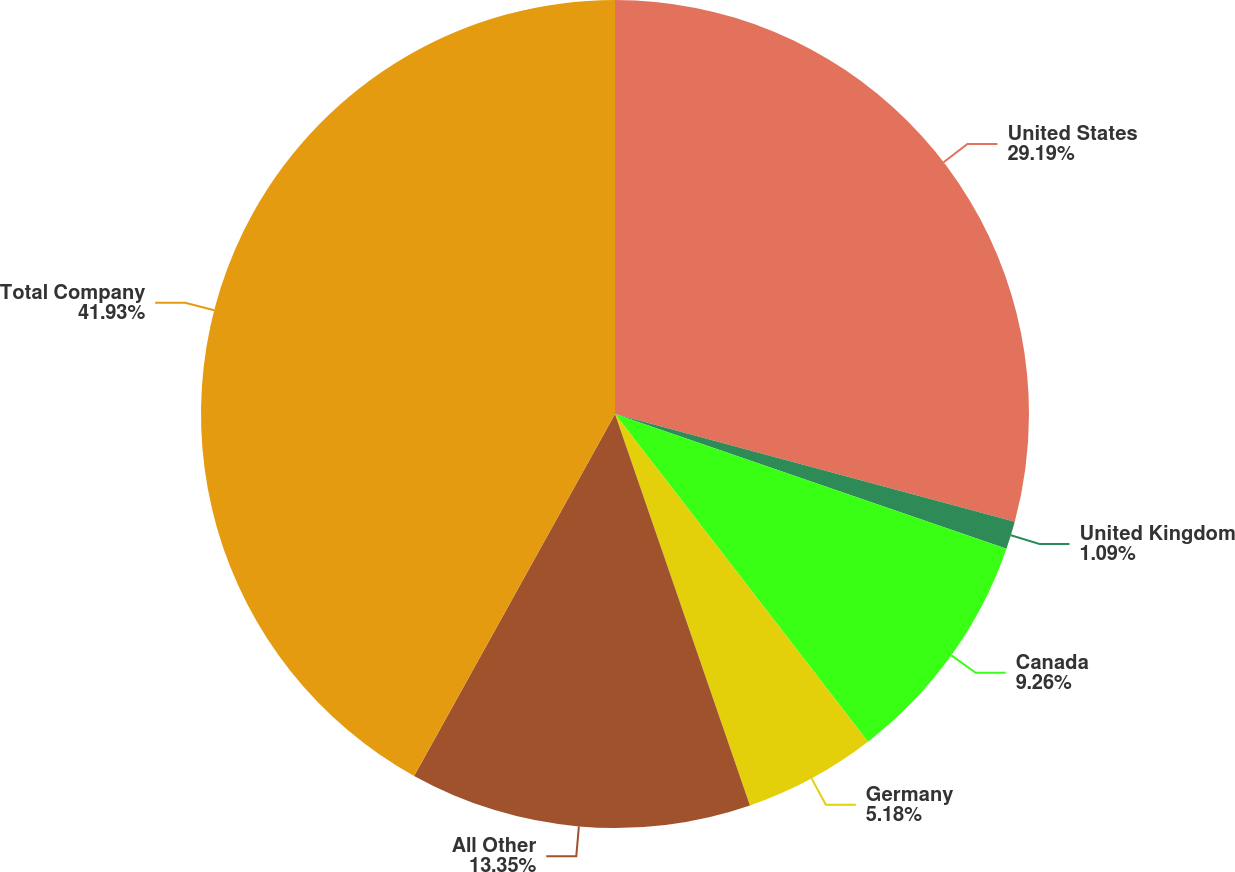<chart> <loc_0><loc_0><loc_500><loc_500><pie_chart><fcel>United States<fcel>United Kingdom<fcel>Canada<fcel>Germany<fcel>All Other<fcel>Total Company<nl><fcel>29.19%<fcel>1.09%<fcel>9.26%<fcel>5.18%<fcel>13.35%<fcel>41.94%<nl></chart> 